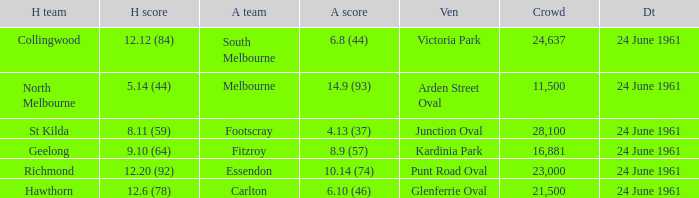Who was the home team that scored 12.6 (78)? Hawthorn. 